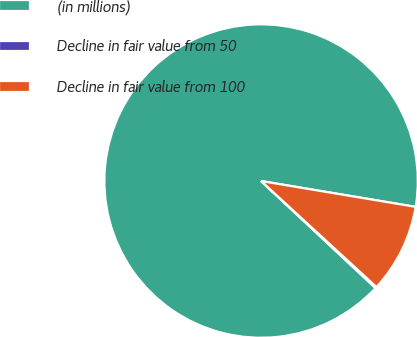<chart> <loc_0><loc_0><loc_500><loc_500><pie_chart><fcel>(in millions)<fcel>Decline in fair value from 50<fcel>Decline in fair value from 100<nl><fcel>90.68%<fcel>0.14%<fcel>9.19%<nl></chart> 